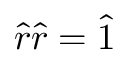<formula> <loc_0><loc_0><loc_500><loc_500>\hat { r } \hat { r } = \hat { 1 }</formula> 